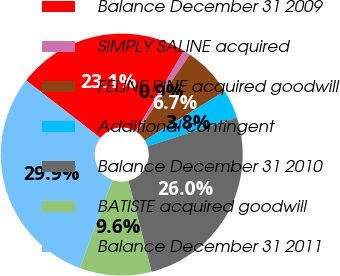Convert chart to OTSL. <chart><loc_0><loc_0><loc_500><loc_500><pie_chart><fcel>Balance December 31 2009<fcel>SIMPLY SALINE acquired<fcel>FELINE PINE acquired goodwill<fcel>Additional contingent<fcel>Balance December 31 2010<fcel>BATISTE acquired goodwill<fcel>Balance December 31 2011<nl><fcel>23.09%<fcel>0.92%<fcel>6.71%<fcel>3.82%<fcel>25.99%<fcel>9.6%<fcel>29.86%<nl></chart> 